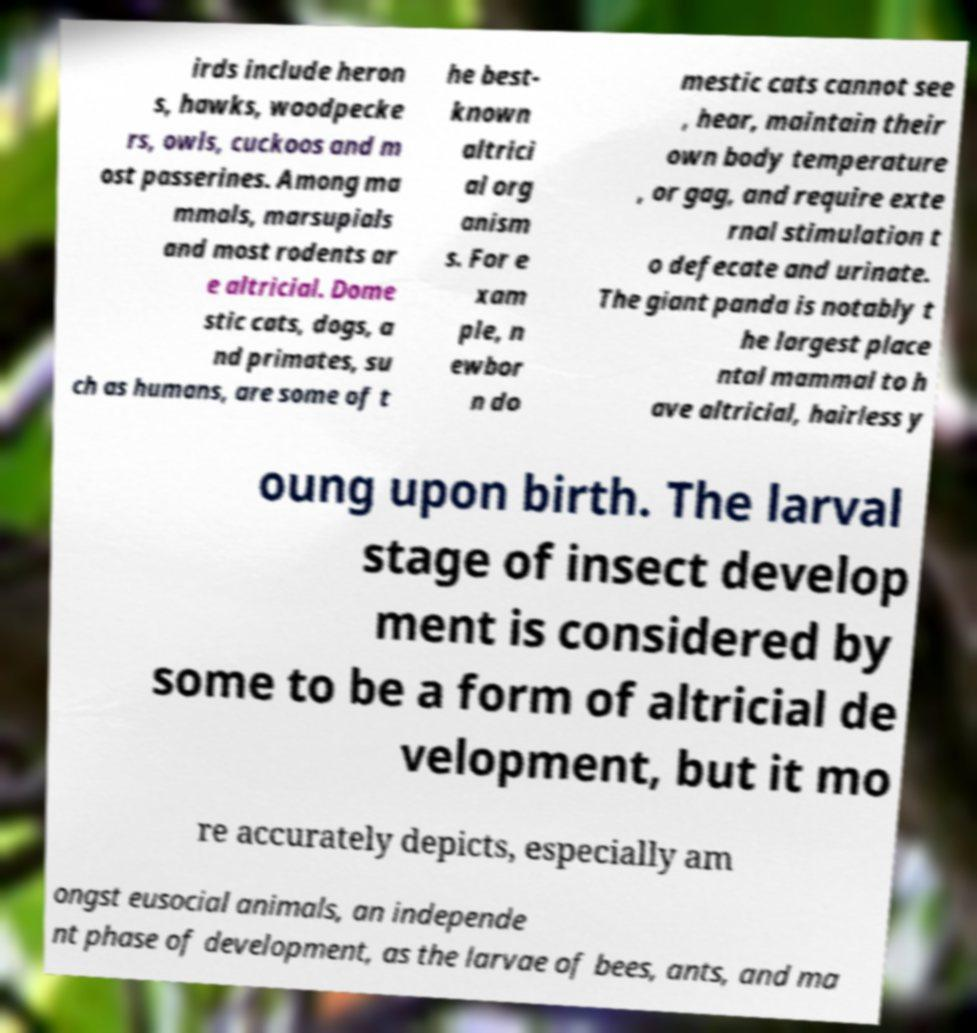There's text embedded in this image that I need extracted. Can you transcribe it verbatim? irds include heron s, hawks, woodpecke rs, owls, cuckoos and m ost passerines. Among ma mmals, marsupials and most rodents ar e altricial. Dome stic cats, dogs, a nd primates, su ch as humans, are some of t he best- known altrici al org anism s. For e xam ple, n ewbor n do mestic cats cannot see , hear, maintain their own body temperature , or gag, and require exte rnal stimulation t o defecate and urinate. The giant panda is notably t he largest place ntal mammal to h ave altricial, hairless y oung upon birth. The larval stage of insect develop ment is considered by some to be a form of altricial de velopment, but it mo re accurately depicts, especially am ongst eusocial animals, an independe nt phase of development, as the larvae of bees, ants, and ma 